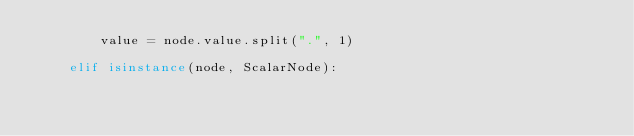Convert code to text. <code><loc_0><loc_0><loc_500><loc_500><_Python_>        value = node.value.split(".", 1)

    elif isinstance(node, ScalarNode):</code> 